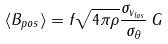<formula> <loc_0><loc_0><loc_500><loc_500>\langle B _ { p o s } \rangle = f \sqrt { 4 \pi \rho } \frac { \sigma _ { v _ { l o s } } } { \sigma _ { \theta } } \, G</formula> 